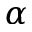Convert formula to latex. <formula><loc_0><loc_0><loc_500><loc_500>\alpha</formula> 